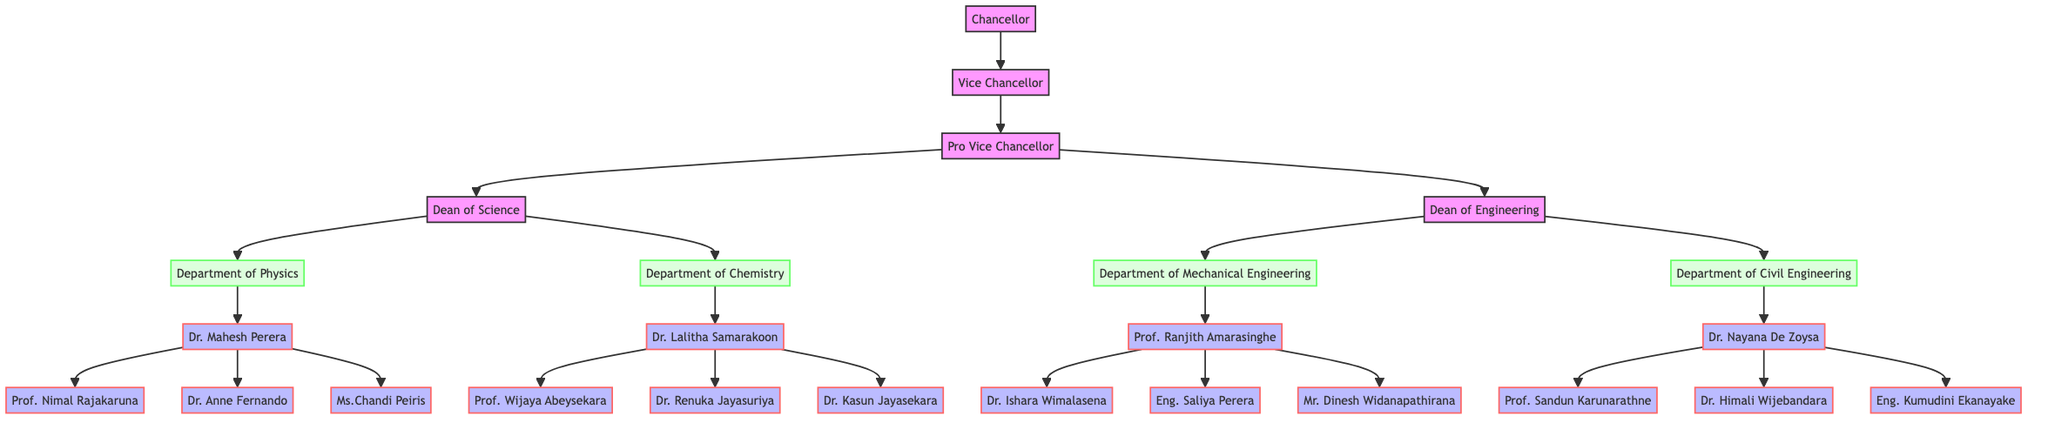What is the title of the topmost position in the university administration? The topmost position, which is represented at the start of the hierarchical structure, is labeled as "Chancellor."
Answer: Chancellor How many faculties does the Pro Vice Chancellor oversee? The Pro Vice Chancellor supervises two faculties, specifically "Faculty Of Science" and "Faculty Of Engineering."
Answer: 2 Who is the Head of the Department of Chemistry? In the diagram, the Head of the Department of Chemistry is identified as "Dr. Lalitha Samarakoon."
Answer: Dr. Lalitha Samarakoon Which faculty does the Head of the Department of Mechanical Engineering belong to? The Head of the Department of Mechanical Engineering, "Prof. Ranjith Amarasinghe," is part of the "Faculty Of Engineering."
Answer: Faculty Of Engineering How many faculty members are under the Head of the Department of Civil Engineering? The Head of the Department of Civil Engineering, "Dr. Nayana De Zoysa," supervises three faculty members indicated in the diagram.
Answer: 3 What position reports directly to the Vice Chancellor? The position that reports directly to the Vice Chancellor is labeled as "Pro Vice Chancellor."
Answer: Pro Vice Chancellor How many total departments are there in the Faculty of Science? In the Faculty of Science, there are two departments represented: the Department of Physics and the Department of Chemistry.
Answer: 2 Which department has the most faculty members listed? The Department of Physics is the one with the most faculty members, as it lists three members in its details.
Answer: Department of Physics What is the level of hierarchy between the Dean of Science and the Chancellor? The hierarchy indicates that the Dean of Science is directly below the Pro Vice Chancellor, who in turn is below the Vice Chancellor, and finally below the Chancellor, making it a three-level descent.
Answer: 3 levels 